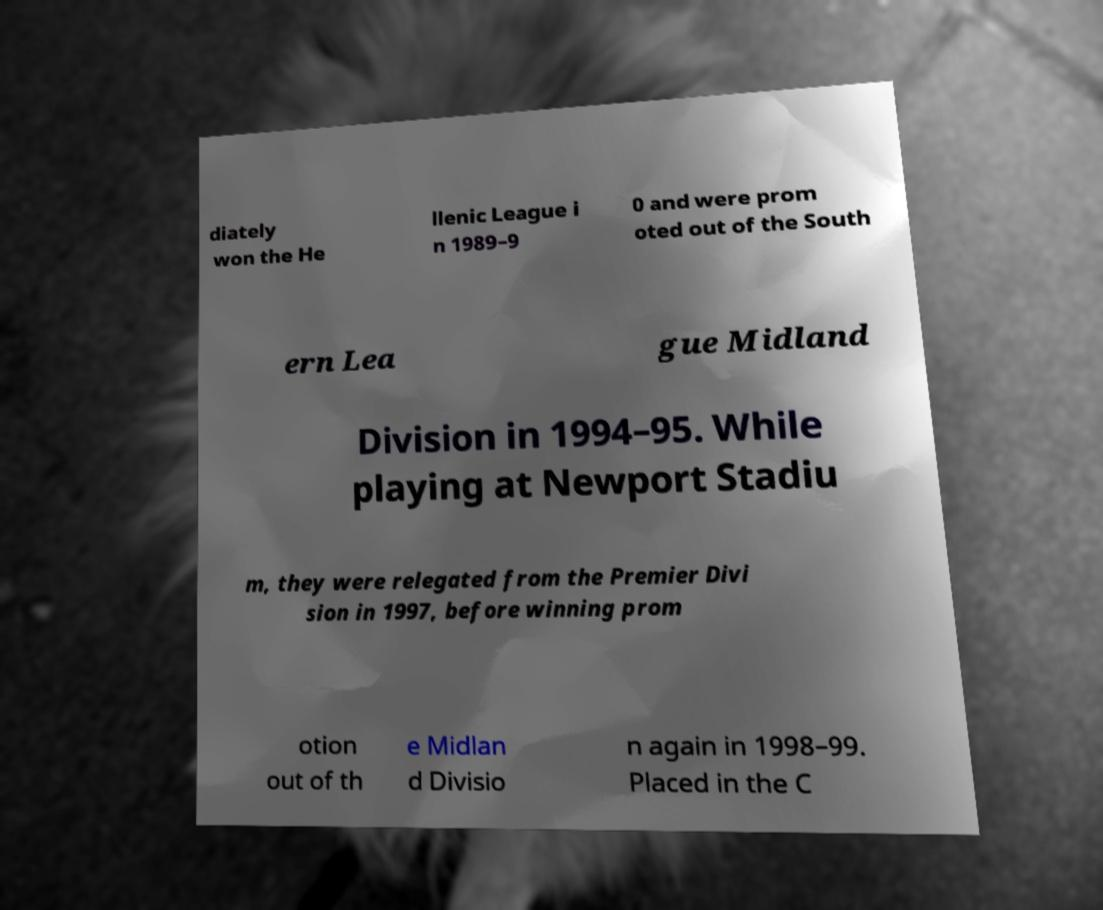Can you accurately transcribe the text from the provided image for me? diately won the He llenic League i n 1989–9 0 and were prom oted out of the South ern Lea gue Midland Division in 1994–95. While playing at Newport Stadiu m, they were relegated from the Premier Divi sion in 1997, before winning prom otion out of th e Midlan d Divisio n again in 1998–99. Placed in the C 